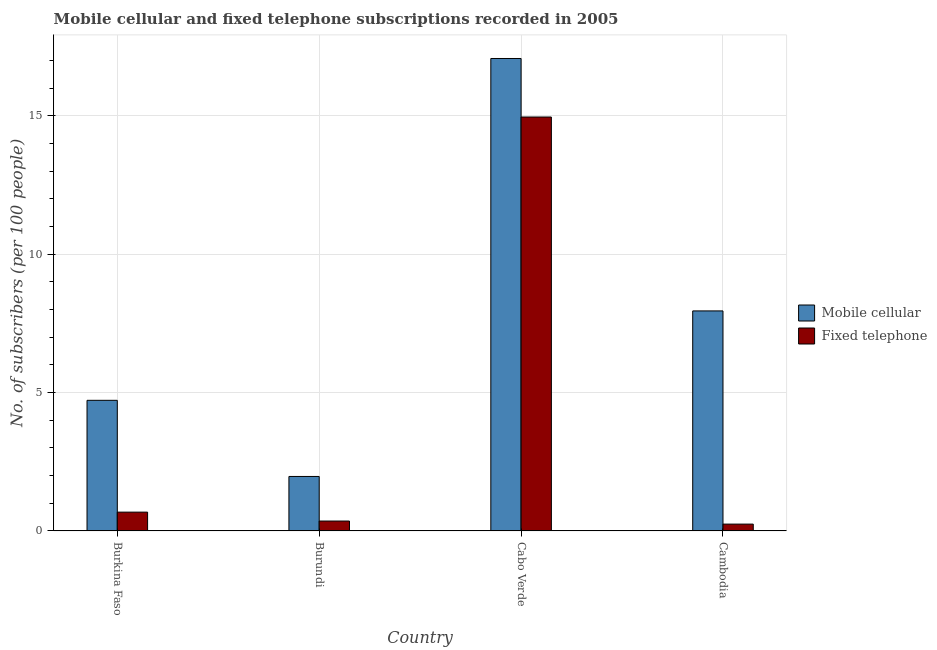Are the number of bars on each tick of the X-axis equal?
Keep it short and to the point. Yes. How many bars are there on the 1st tick from the left?
Your answer should be very brief. 2. What is the label of the 1st group of bars from the left?
Ensure brevity in your answer.  Burkina Faso. What is the number of fixed telephone subscribers in Burundi?
Your response must be concise. 0.36. Across all countries, what is the maximum number of fixed telephone subscribers?
Your response must be concise. 14.96. Across all countries, what is the minimum number of fixed telephone subscribers?
Provide a succinct answer. 0.25. In which country was the number of fixed telephone subscribers maximum?
Offer a very short reply. Cabo Verde. In which country was the number of mobile cellular subscribers minimum?
Give a very brief answer. Burundi. What is the total number of fixed telephone subscribers in the graph?
Your answer should be very brief. 16.24. What is the difference between the number of fixed telephone subscribers in Burkina Faso and that in Cambodia?
Ensure brevity in your answer.  0.43. What is the difference between the number of fixed telephone subscribers in Cambodia and the number of mobile cellular subscribers in Burkina Faso?
Your response must be concise. -4.47. What is the average number of mobile cellular subscribers per country?
Ensure brevity in your answer.  7.93. What is the difference between the number of fixed telephone subscribers and number of mobile cellular subscribers in Cabo Verde?
Offer a terse response. -2.11. What is the ratio of the number of fixed telephone subscribers in Burkina Faso to that in Cambodia?
Provide a short and direct response. 2.75. Is the number of fixed telephone subscribers in Burkina Faso less than that in Cabo Verde?
Your answer should be compact. Yes. What is the difference between the highest and the second highest number of fixed telephone subscribers?
Your response must be concise. 14.28. What is the difference between the highest and the lowest number of mobile cellular subscribers?
Offer a very short reply. 15.1. In how many countries, is the number of mobile cellular subscribers greater than the average number of mobile cellular subscribers taken over all countries?
Your response must be concise. 2. What does the 2nd bar from the left in Cabo Verde represents?
Provide a succinct answer. Fixed telephone. What does the 2nd bar from the right in Burundi represents?
Your answer should be very brief. Mobile cellular. Does the graph contain any zero values?
Your response must be concise. No. Does the graph contain grids?
Make the answer very short. Yes. Where does the legend appear in the graph?
Keep it short and to the point. Center right. How are the legend labels stacked?
Offer a very short reply. Vertical. What is the title of the graph?
Make the answer very short. Mobile cellular and fixed telephone subscriptions recorded in 2005. What is the label or title of the Y-axis?
Keep it short and to the point. No. of subscribers (per 100 people). What is the No. of subscribers (per 100 people) of Mobile cellular in Burkina Faso?
Keep it short and to the point. 4.72. What is the No. of subscribers (per 100 people) in Fixed telephone in Burkina Faso?
Your response must be concise. 0.68. What is the No. of subscribers (per 100 people) of Mobile cellular in Burundi?
Keep it short and to the point. 1.97. What is the No. of subscribers (per 100 people) in Fixed telephone in Burundi?
Ensure brevity in your answer.  0.36. What is the No. of subscribers (per 100 people) in Mobile cellular in Cabo Verde?
Your answer should be very brief. 17.07. What is the No. of subscribers (per 100 people) in Fixed telephone in Cabo Verde?
Give a very brief answer. 14.96. What is the No. of subscribers (per 100 people) in Mobile cellular in Cambodia?
Provide a succinct answer. 7.95. What is the No. of subscribers (per 100 people) of Fixed telephone in Cambodia?
Keep it short and to the point. 0.25. Across all countries, what is the maximum No. of subscribers (per 100 people) of Mobile cellular?
Make the answer very short. 17.07. Across all countries, what is the maximum No. of subscribers (per 100 people) of Fixed telephone?
Your response must be concise. 14.96. Across all countries, what is the minimum No. of subscribers (per 100 people) in Mobile cellular?
Ensure brevity in your answer.  1.97. Across all countries, what is the minimum No. of subscribers (per 100 people) of Fixed telephone?
Ensure brevity in your answer.  0.25. What is the total No. of subscribers (per 100 people) in Mobile cellular in the graph?
Keep it short and to the point. 31.71. What is the total No. of subscribers (per 100 people) of Fixed telephone in the graph?
Provide a succinct answer. 16.24. What is the difference between the No. of subscribers (per 100 people) in Mobile cellular in Burkina Faso and that in Burundi?
Your response must be concise. 2.75. What is the difference between the No. of subscribers (per 100 people) in Fixed telephone in Burkina Faso and that in Burundi?
Offer a terse response. 0.32. What is the difference between the No. of subscribers (per 100 people) in Mobile cellular in Burkina Faso and that in Cabo Verde?
Keep it short and to the point. -12.35. What is the difference between the No. of subscribers (per 100 people) of Fixed telephone in Burkina Faso and that in Cabo Verde?
Your answer should be compact. -14.28. What is the difference between the No. of subscribers (per 100 people) in Mobile cellular in Burkina Faso and that in Cambodia?
Ensure brevity in your answer.  -3.23. What is the difference between the No. of subscribers (per 100 people) of Fixed telephone in Burkina Faso and that in Cambodia?
Your response must be concise. 0.43. What is the difference between the No. of subscribers (per 100 people) of Mobile cellular in Burundi and that in Cabo Verde?
Your answer should be compact. -15.1. What is the difference between the No. of subscribers (per 100 people) of Fixed telephone in Burundi and that in Cabo Verde?
Give a very brief answer. -14.6. What is the difference between the No. of subscribers (per 100 people) of Mobile cellular in Burundi and that in Cambodia?
Offer a terse response. -5.98. What is the difference between the No. of subscribers (per 100 people) in Fixed telephone in Burundi and that in Cambodia?
Your answer should be very brief. 0.11. What is the difference between the No. of subscribers (per 100 people) of Mobile cellular in Cabo Verde and that in Cambodia?
Provide a succinct answer. 9.12. What is the difference between the No. of subscribers (per 100 people) of Fixed telephone in Cabo Verde and that in Cambodia?
Offer a terse response. 14.71. What is the difference between the No. of subscribers (per 100 people) in Mobile cellular in Burkina Faso and the No. of subscribers (per 100 people) in Fixed telephone in Burundi?
Your response must be concise. 4.36. What is the difference between the No. of subscribers (per 100 people) in Mobile cellular in Burkina Faso and the No. of subscribers (per 100 people) in Fixed telephone in Cabo Verde?
Your answer should be very brief. -10.24. What is the difference between the No. of subscribers (per 100 people) in Mobile cellular in Burkina Faso and the No. of subscribers (per 100 people) in Fixed telephone in Cambodia?
Your response must be concise. 4.47. What is the difference between the No. of subscribers (per 100 people) of Mobile cellular in Burundi and the No. of subscribers (per 100 people) of Fixed telephone in Cabo Verde?
Provide a succinct answer. -12.99. What is the difference between the No. of subscribers (per 100 people) of Mobile cellular in Burundi and the No. of subscribers (per 100 people) of Fixed telephone in Cambodia?
Your response must be concise. 1.72. What is the difference between the No. of subscribers (per 100 people) in Mobile cellular in Cabo Verde and the No. of subscribers (per 100 people) in Fixed telephone in Cambodia?
Offer a terse response. 16.83. What is the average No. of subscribers (per 100 people) of Mobile cellular per country?
Your answer should be compact. 7.93. What is the average No. of subscribers (per 100 people) of Fixed telephone per country?
Make the answer very short. 4.06. What is the difference between the No. of subscribers (per 100 people) of Mobile cellular and No. of subscribers (per 100 people) of Fixed telephone in Burkina Faso?
Give a very brief answer. 4.04. What is the difference between the No. of subscribers (per 100 people) in Mobile cellular and No. of subscribers (per 100 people) in Fixed telephone in Burundi?
Give a very brief answer. 1.61. What is the difference between the No. of subscribers (per 100 people) in Mobile cellular and No. of subscribers (per 100 people) in Fixed telephone in Cabo Verde?
Ensure brevity in your answer.  2.11. What is the difference between the No. of subscribers (per 100 people) in Mobile cellular and No. of subscribers (per 100 people) in Fixed telephone in Cambodia?
Your answer should be very brief. 7.7. What is the ratio of the No. of subscribers (per 100 people) of Mobile cellular in Burkina Faso to that in Burundi?
Keep it short and to the point. 2.4. What is the ratio of the No. of subscribers (per 100 people) of Fixed telephone in Burkina Faso to that in Burundi?
Keep it short and to the point. 1.9. What is the ratio of the No. of subscribers (per 100 people) of Mobile cellular in Burkina Faso to that in Cabo Verde?
Ensure brevity in your answer.  0.28. What is the ratio of the No. of subscribers (per 100 people) of Fixed telephone in Burkina Faso to that in Cabo Verde?
Keep it short and to the point. 0.05. What is the ratio of the No. of subscribers (per 100 people) in Mobile cellular in Burkina Faso to that in Cambodia?
Make the answer very short. 0.59. What is the ratio of the No. of subscribers (per 100 people) of Fixed telephone in Burkina Faso to that in Cambodia?
Your response must be concise. 2.75. What is the ratio of the No. of subscribers (per 100 people) of Mobile cellular in Burundi to that in Cabo Verde?
Ensure brevity in your answer.  0.12. What is the ratio of the No. of subscribers (per 100 people) in Fixed telephone in Burundi to that in Cabo Verde?
Offer a terse response. 0.02. What is the ratio of the No. of subscribers (per 100 people) in Mobile cellular in Burundi to that in Cambodia?
Provide a succinct answer. 0.25. What is the ratio of the No. of subscribers (per 100 people) of Fixed telephone in Burundi to that in Cambodia?
Ensure brevity in your answer.  1.45. What is the ratio of the No. of subscribers (per 100 people) in Mobile cellular in Cabo Verde to that in Cambodia?
Make the answer very short. 2.15. What is the ratio of the No. of subscribers (per 100 people) of Fixed telephone in Cabo Verde to that in Cambodia?
Make the answer very short. 60.6. What is the difference between the highest and the second highest No. of subscribers (per 100 people) in Mobile cellular?
Your response must be concise. 9.12. What is the difference between the highest and the second highest No. of subscribers (per 100 people) of Fixed telephone?
Make the answer very short. 14.28. What is the difference between the highest and the lowest No. of subscribers (per 100 people) of Mobile cellular?
Make the answer very short. 15.1. What is the difference between the highest and the lowest No. of subscribers (per 100 people) in Fixed telephone?
Provide a short and direct response. 14.71. 